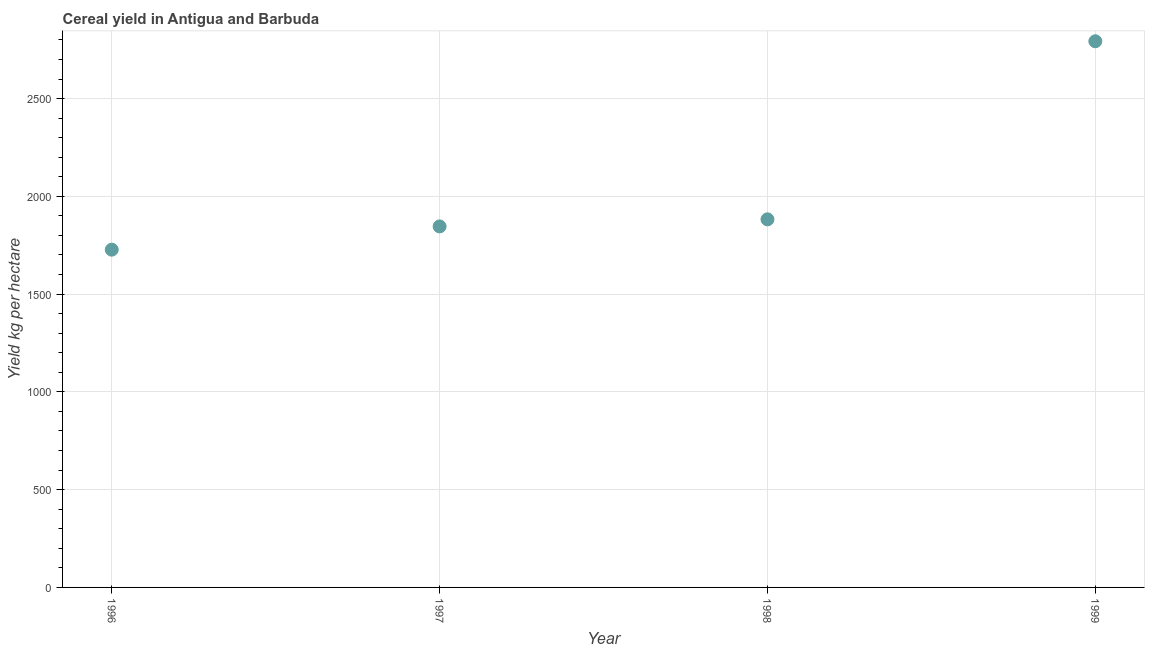What is the cereal yield in 1996?
Keep it short and to the point. 1727.27. Across all years, what is the maximum cereal yield?
Offer a terse response. 2793.1. Across all years, what is the minimum cereal yield?
Your answer should be very brief. 1727.27. In which year was the cereal yield maximum?
Provide a succinct answer. 1999. What is the sum of the cereal yield?
Your answer should be compact. 8248.88. What is the difference between the cereal yield in 1996 and 1997?
Provide a short and direct response. -118.88. What is the average cereal yield per year?
Ensure brevity in your answer.  2062.22. What is the median cereal yield?
Provide a succinct answer. 1864.25. In how many years, is the cereal yield greater than 2300 kg per hectare?
Your answer should be compact. 1. What is the ratio of the cereal yield in 1997 to that in 1998?
Provide a succinct answer. 0.98. Is the difference between the cereal yield in 1996 and 1997 greater than the difference between any two years?
Offer a terse response. No. What is the difference between the highest and the second highest cereal yield?
Provide a short and direct response. 910.75. Is the sum of the cereal yield in 1998 and 1999 greater than the maximum cereal yield across all years?
Your response must be concise. Yes. What is the difference between the highest and the lowest cereal yield?
Make the answer very short. 1065.83. Does the cereal yield monotonically increase over the years?
Keep it short and to the point. Yes. What is the difference between two consecutive major ticks on the Y-axis?
Give a very brief answer. 500. Does the graph contain any zero values?
Your answer should be compact. No. What is the title of the graph?
Provide a short and direct response. Cereal yield in Antigua and Barbuda. What is the label or title of the Y-axis?
Provide a short and direct response. Yield kg per hectare. What is the Yield kg per hectare in 1996?
Provide a succinct answer. 1727.27. What is the Yield kg per hectare in 1997?
Ensure brevity in your answer.  1846.15. What is the Yield kg per hectare in 1998?
Ensure brevity in your answer.  1882.35. What is the Yield kg per hectare in 1999?
Keep it short and to the point. 2793.1. What is the difference between the Yield kg per hectare in 1996 and 1997?
Make the answer very short. -118.88. What is the difference between the Yield kg per hectare in 1996 and 1998?
Provide a short and direct response. -155.08. What is the difference between the Yield kg per hectare in 1996 and 1999?
Give a very brief answer. -1065.83. What is the difference between the Yield kg per hectare in 1997 and 1998?
Provide a short and direct response. -36.2. What is the difference between the Yield kg per hectare in 1997 and 1999?
Offer a terse response. -946.95. What is the difference between the Yield kg per hectare in 1998 and 1999?
Ensure brevity in your answer.  -910.75. What is the ratio of the Yield kg per hectare in 1996 to that in 1997?
Your answer should be very brief. 0.94. What is the ratio of the Yield kg per hectare in 1996 to that in 1998?
Provide a short and direct response. 0.92. What is the ratio of the Yield kg per hectare in 1996 to that in 1999?
Your answer should be compact. 0.62. What is the ratio of the Yield kg per hectare in 1997 to that in 1999?
Your response must be concise. 0.66. What is the ratio of the Yield kg per hectare in 1998 to that in 1999?
Keep it short and to the point. 0.67. 